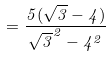Convert formula to latex. <formula><loc_0><loc_0><loc_500><loc_500>= { \frac { 5 ( { \sqrt { 3 } } - 4 ) } { { \sqrt { 3 } } ^ { 2 } - 4 ^ { 2 } } }</formula> 